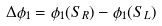<formula> <loc_0><loc_0><loc_500><loc_500>\Delta \phi _ { 1 } = \phi _ { 1 } ( S _ { R } ) - \phi _ { 1 } ( S _ { L } )</formula> 